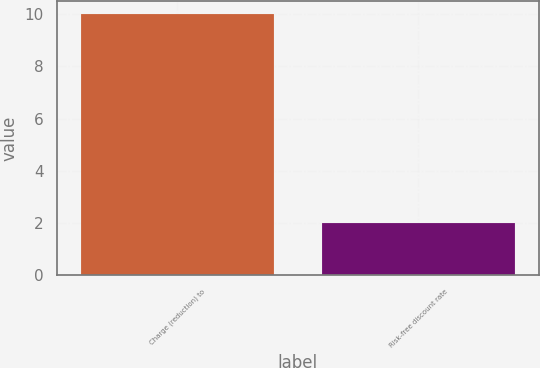Convert chart. <chart><loc_0><loc_0><loc_500><loc_500><bar_chart><fcel>Charge (reduction) to<fcel>Risk-free discount rate<nl><fcel>10<fcel>2<nl></chart> 